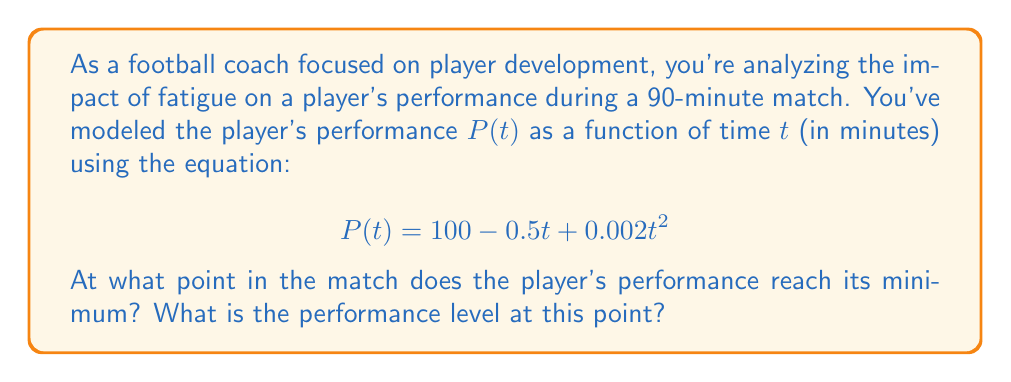Give your solution to this math problem. To solve this problem, we need to follow these steps:

1) First, we need to find the minimum point of the function $P(t)$. In calculus, we know that the minimum (or maximum) of a function occurs where its derivative equals zero.

2) Let's find the derivative of $P(t)$:

   $$P'(t) = -0.5 + 0.004t$$

3) Now, let's set this equal to zero and solve for $t$:

   $$-0.5 + 0.004t = 0$$
   $$0.004t = 0.5$$
   $$t = 125$$

4) This tells us that the minimum occurs at $t = 125$ minutes. However, we need to consider the context of our problem. A football match only lasts 90 minutes, so the actual minimum within our time frame will occur at the end of the match, at $t = 90$ minutes.

5) To find the performance level at this point, we plug $t = 90$ into our original equation:

   $$P(90) = 100 - 0.5(90) + 0.002(90)^2$$
   $$= 100 - 45 + 0.002(8100)$$
   $$= 55 + 16.2$$
   $$= 71.2$$

This analysis shows that player fatigue causes performance to decline throughout the match, reaching its lowest point at the final whistle. This information is crucial for developing strategies to manage player energy and considering substitutions.
Answer: The player's performance reaches its minimum at the end of the match (90 minutes), with a performance level of 71.2. 